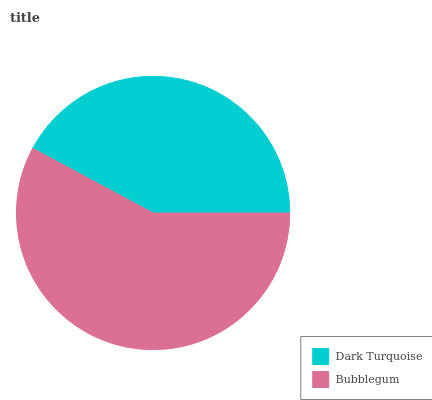Is Dark Turquoise the minimum?
Answer yes or no. Yes. Is Bubblegum the maximum?
Answer yes or no. Yes. Is Bubblegum the minimum?
Answer yes or no. No. Is Bubblegum greater than Dark Turquoise?
Answer yes or no. Yes. Is Dark Turquoise less than Bubblegum?
Answer yes or no. Yes. Is Dark Turquoise greater than Bubblegum?
Answer yes or no. No. Is Bubblegum less than Dark Turquoise?
Answer yes or no. No. Is Bubblegum the high median?
Answer yes or no. Yes. Is Dark Turquoise the low median?
Answer yes or no. Yes. Is Dark Turquoise the high median?
Answer yes or no. No. Is Bubblegum the low median?
Answer yes or no. No. 